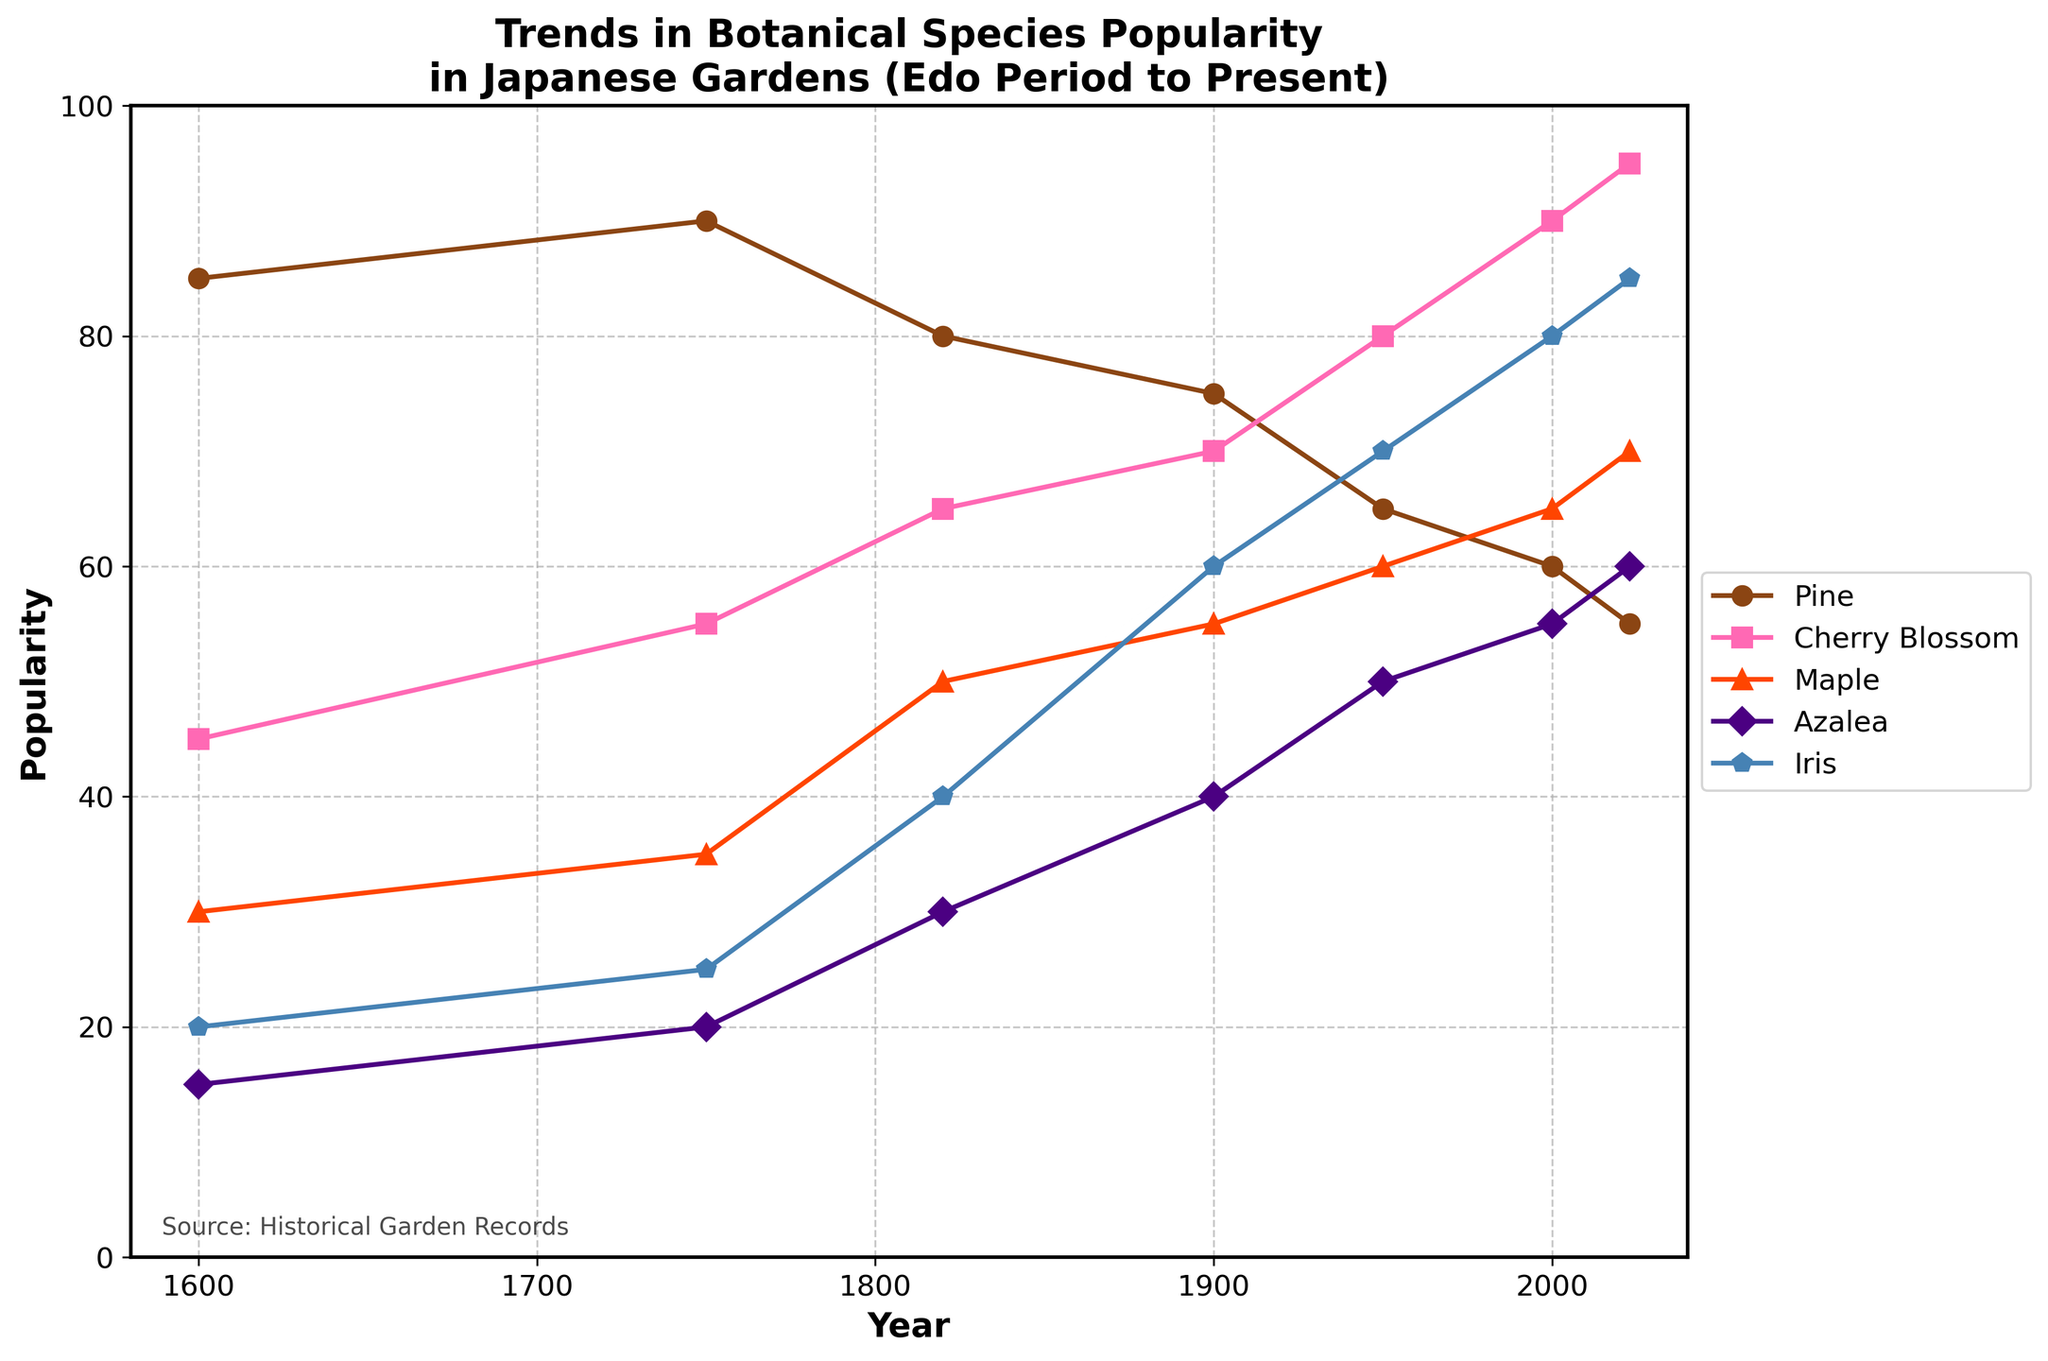What is the title of the figure? The title of the figure is shown in bold at the top of the plot. The text reads: "Trends in Botanical Species Popularity in Japanese Gardens (Edo Period to Present)"
Answer: Trends in Botanical Species Popularity in Japanese Gardens (Edo Period to Present) How many species are tracked in the figure? By observing the legend on the right side of the plot, we see five species listed: Pine, Cherry Blossom, Maple, Azalea, and Iris
Answer: 5 Which species had the highest popularity in 2023? By looking at the highest data point for the year 2023 on the x-axis, the species with the highest popularity is 'Cherry Blossom' at a value of 95.
Answer: Cherry Blossom Which species showed a consistent increase in popularity over time? To determine this, observe each species' trend lines from 1600 to 2023. The only species that consistently increases in popularity is the Cherry Blossom.
Answer: Cherry Blossom What is the trend in Pine's popularity from 1600 to 2023? Analyzing Pine's line from 1600 to 2023, we notice a decreasing trend. It starts at 85 in 1600 and declines to 55 in 2023.
Answer: Decreasing In which year did Iris first surpass Azalea in popularity? By examining the intersection of Iris and Azalea lines, we notice that Iris' line surpasses Azalea for the first time around the year 1900.
Answer: 1900 Which species had the lowest popularity in 1600 and what was its value? By looking at the data points for the year 1600, the Azalea had the lowest popularity with a value of 15.
Answer: Azalea, 15 Calculate the change in popularity for Maple from 1900 to 2023. In 1900, Maple's popularity is 55. In 2023, it is 70. The change is 70 - 55 = 15.
Answer: 15 Between 1950 and 2000, which species experienced the largest increase in popularity? We examine the lines for each species between 1950 and 2000. Cherry Blossom increased from 80 to 90 (increase of 10), Iris increased from 70 to 80 (increase of 10), Pine decreased, Maple increased by 5, and Azalea increased by 5. Therefore, Cherry Blossom and Iris had the largest increase of 10.
Answer: Cherry Blossom and Iris What species consistently remained above a popularity of 50 from 1600 to 2023? By evaluating the plot for each species' line, only Pine consistently stays above 50 popularity throughout the entire time period.
Answer: Pine 